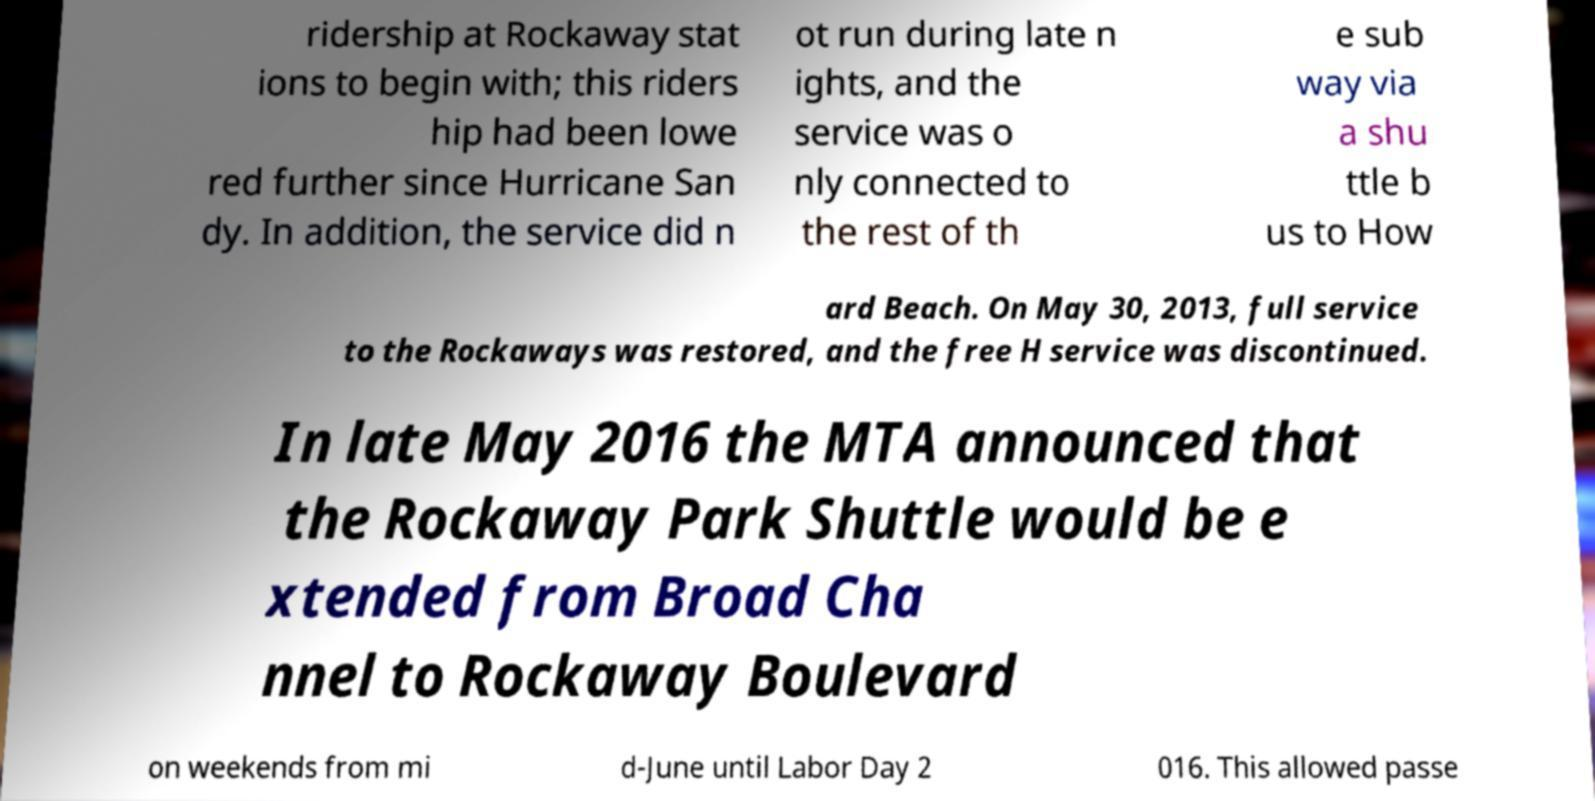What messages or text are displayed in this image? I need them in a readable, typed format. ridership at Rockaway stat ions to begin with; this riders hip had been lowe red further since Hurricane San dy. In addition, the service did n ot run during late n ights, and the service was o nly connected to the rest of th e sub way via a shu ttle b us to How ard Beach. On May 30, 2013, full service to the Rockaways was restored, and the free H service was discontinued. In late May 2016 the MTA announced that the Rockaway Park Shuttle would be e xtended from Broad Cha nnel to Rockaway Boulevard on weekends from mi d-June until Labor Day 2 016. This allowed passe 